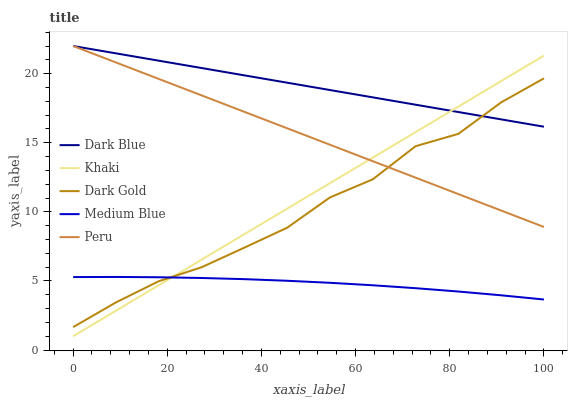Does Khaki have the minimum area under the curve?
Answer yes or no. No. Does Khaki have the maximum area under the curve?
Answer yes or no. No. Is Khaki the smoothest?
Answer yes or no. No. Is Khaki the roughest?
Answer yes or no. No. Does Medium Blue have the lowest value?
Answer yes or no. No. Does Khaki have the highest value?
Answer yes or no. No. Is Medium Blue less than Peru?
Answer yes or no. Yes. Is Peru greater than Medium Blue?
Answer yes or no. Yes. Does Medium Blue intersect Peru?
Answer yes or no. No. 